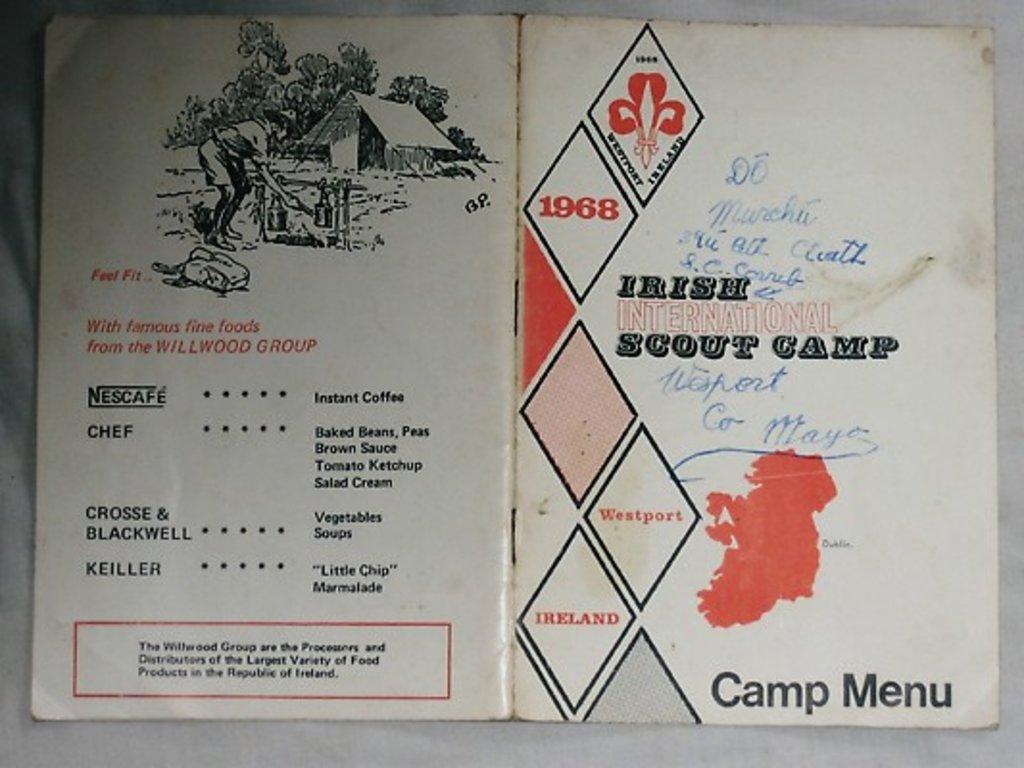Which year is this booklet published?
Make the answer very short. 1968. Is this a camp menu?
Your answer should be compact. Yes. 